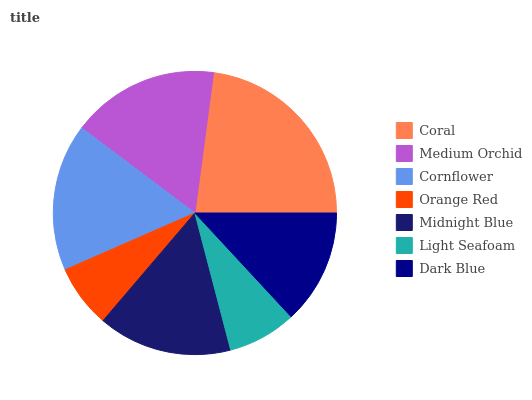Is Orange Red the minimum?
Answer yes or no. Yes. Is Coral the maximum?
Answer yes or no. Yes. Is Medium Orchid the minimum?
Answer yes or no. No. Is Medium Orchid the maximum?
Answer yes or no. No. Is Coral greater than Medium Orchid?
Answer yes or no. Yes. Is Medium Orchid less than Coral?
Answer yes or no. Yes. Is Medium Orchid greater than Coral?
Answer yes or no. No. Is Coral less than Medium Orchid?
Answer yes or no. No. Is Midnight Blue the high median?
Answer yes or no. Yes. Is Midnight Blue the low median?
Answer yes or no. Yes. Is Orange Red the high median?
Answer yes or no. No. Is Cornflower the low median?
Answer yes or no. No. 